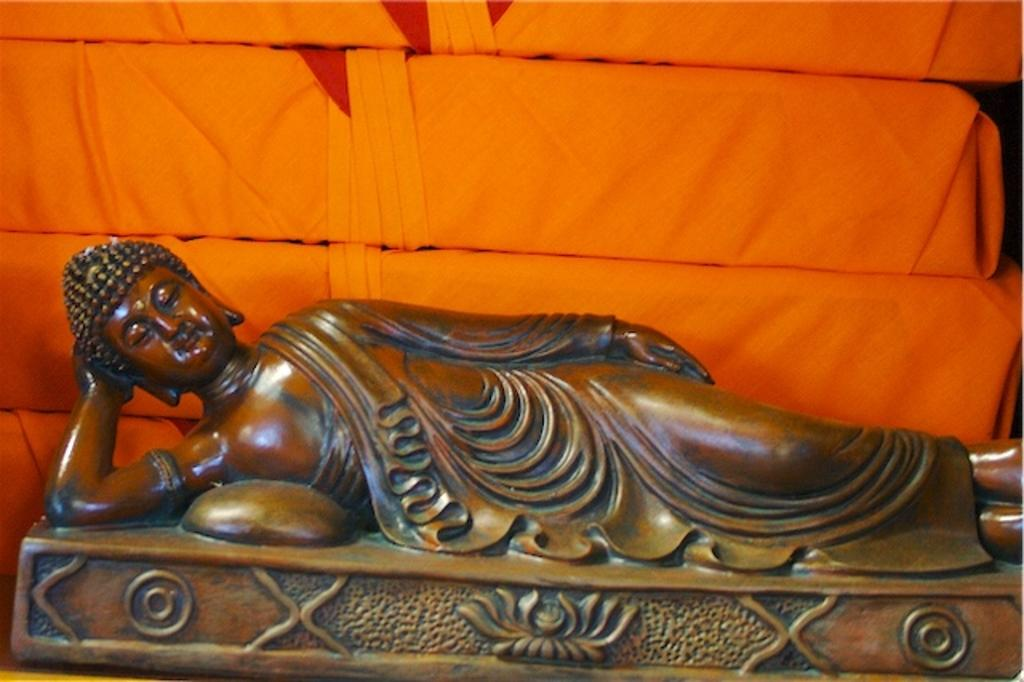What is the main subject of the image? There is a sculpture of a person in the image. What is the sculpture resting on? The sculpture is lying on a brown surface. What can be seen in the background of the image? There are a few orange objects visible in the background. How many pieces of pie are on the sculpture's head in the image? There are no pies present in the image; it features a sculpture of a person lying on a brown surface with orange objects in the background. 